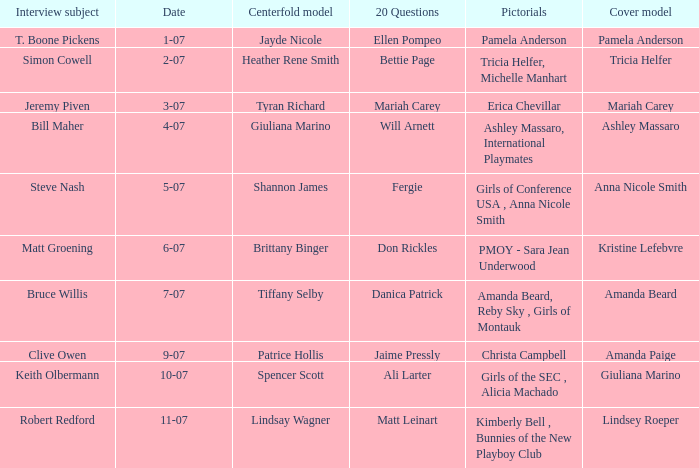List the pictorals from issues when lindsey roeper was the cover model. Kimberly Bell , Bunnies of the New Playboy Club. 